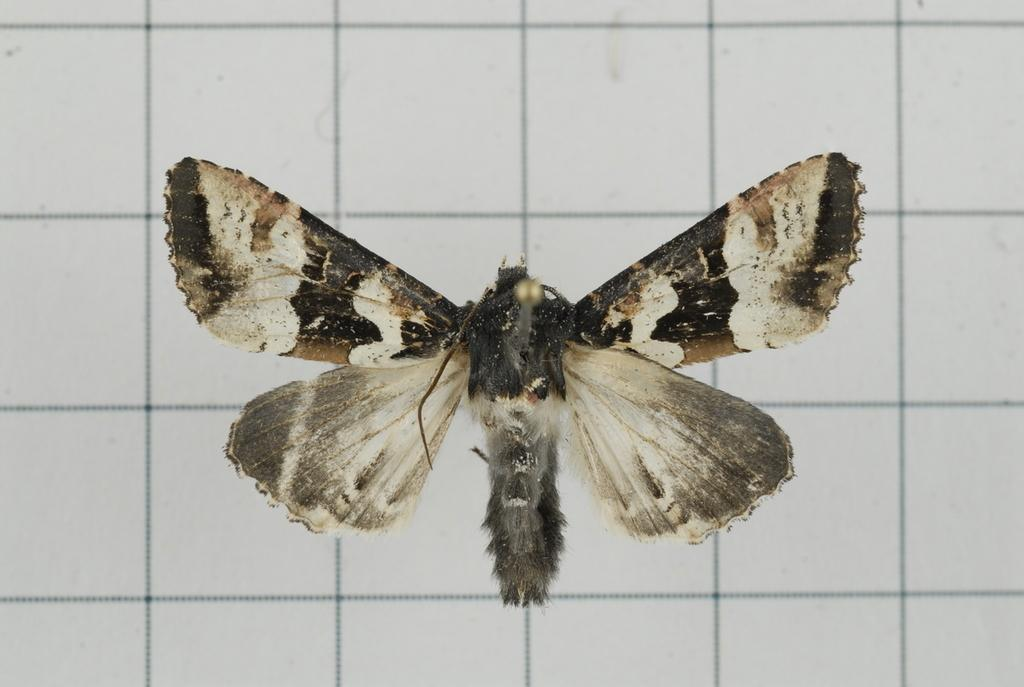What type of creature can be seen in the image? There is an insect in the image. What is visible in the background of the image? There is a wall in the background of the image. What type of kite is the farmer flying in the image? There is no farmer or kite present in the image; it only features an insect and a wall in the background. 